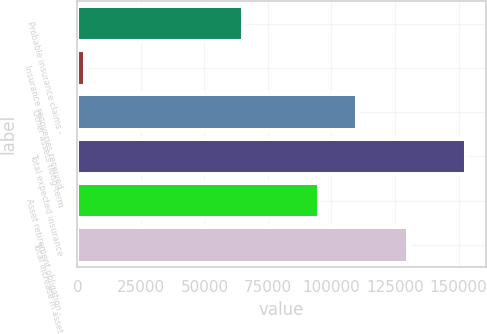<chart> <loc_0><loc_0><loc_500><loc_500><bar_chart><fcel>Probable insurance claims -<fcel>Insurance recoveries received<fcel>Other assets (long-term<fcel>Total expected insurance<fcel>Asset retirement obligation -<fcel>Total increase in asset<nl><fcel>65000<fcel>3146<fcel>109950<fcel>152978<fcel>94966.4<fcel>130000<nl></chart> 